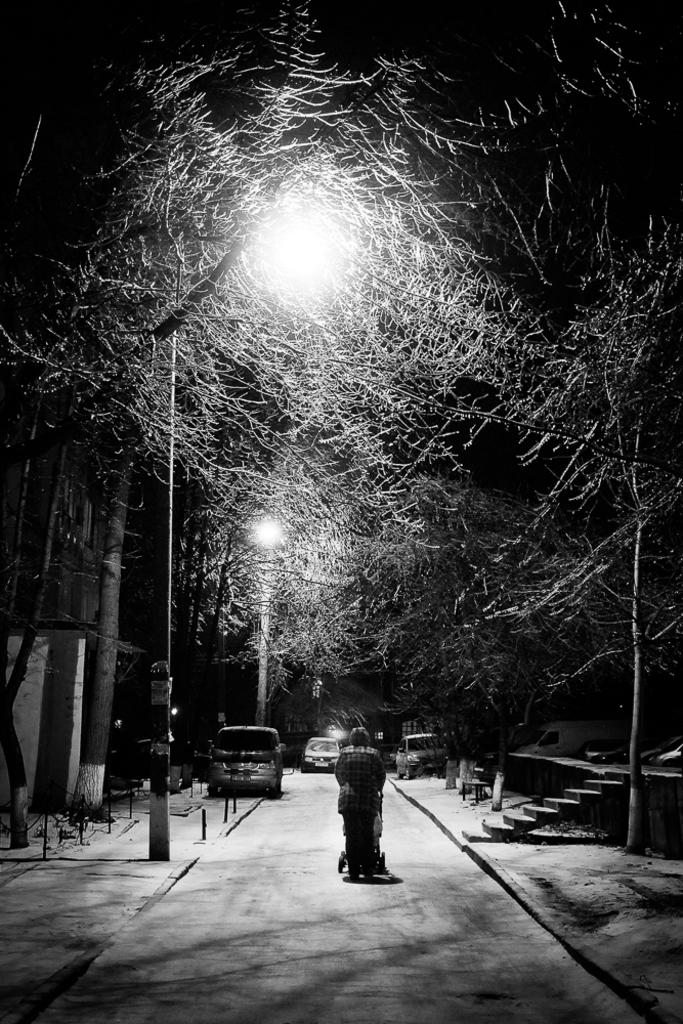What is the main subject of the image? There is a person walking in the center of the image. What can be seen in the background of the image? There are trees, vehicles, and poles in the background of the image. Where is the staircase located in the image? The staircase is on the right side of the image. How many clocks are hanging on the trees in the image? There are no clocks hanging on the trees in the image. Can you see a worm crawling on the person walking in the image? There is no worm present in the image. 